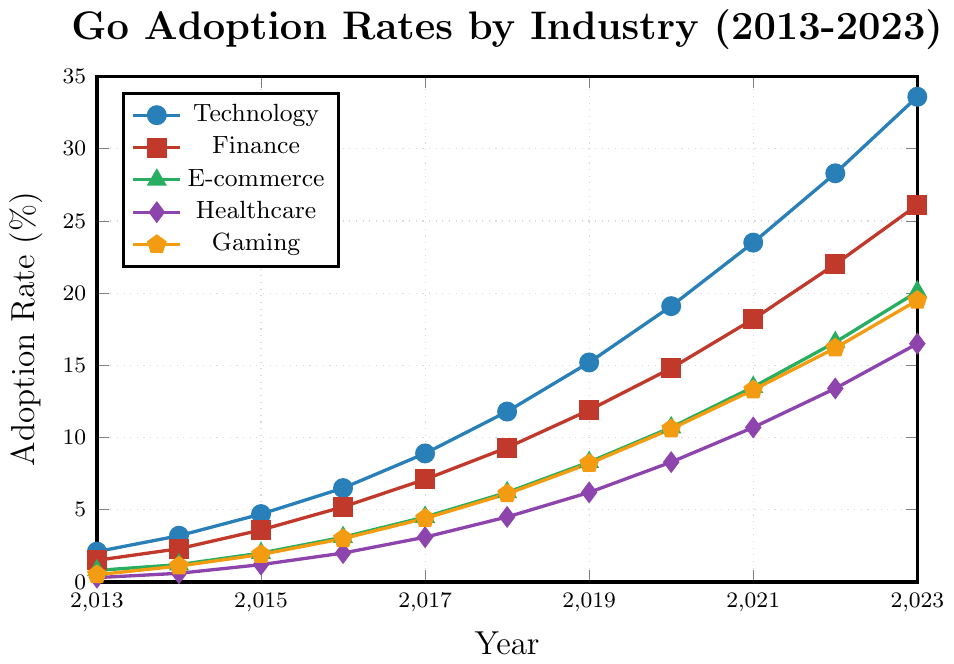What was the highest adoption rate of Go in the Technology sector across the years? From the plot, we observe that the Go adoption rate in the Technology sector reaches its highest at 33.6% in the year 2023.
Answer: 33.6% Which sector had the lowest adoption rate of Go in 2015? By looking at the plot for the year 2015, the Healthcare sector shows the lowest adoption rate of Go at 1.2%.
Answer: Healthcare By how much did the adoption rate of Go in the Finance sector increase from 2016 to 2020? The adoption rate for Finance in 2016 was 5.2% and 14.8% in 2020. The increase is calculated as 14.8 - 5.2 = 9.6%.
Answer: 9.6% What is the difference between the adoption rate of Go in the Gaming sector between 2019 and 2023? According to the plot, the adoption rate in the Gaming sector for 2019 was 8.2% and for 2023 it was 19.5%. The difference is 19.5 - 8.2 = 11.3%.
Answer: 11.3% In which year did E-commerce surpass a 10% adoption rate of Go? Referring to the E-commerce line in the plot, we see that it just surpassed 10% in 2020 with an adoption rate of 10.7%.
Answer: 2020 How much did the Healthcare sector’s adoption rate of Go increase from 2013 to 2023? For Healthcare, the adoption rate went from 0.3% in 2013 to 16.5% in 2023. The increase is 16.5 - 0.3 = 16.2%.
Answer: 16.2% Which sector saw the most significant growth in the adoption rate of Go between 2013 and 2023? By visually comparing all the sectors, the Technology sector shows the most significant growth from 2.1% in 2013 to 33.6% in 2023. This is a total increase of 33.6 - 2.1 = 31.5%.
Answer: Technology Rank the sectors by their Go adoption rates in 2023. In 2023, the Go adoption rates are: Technology (33.6%), Finance (26.1%), E-commerce (20.1%), Gaming (19.5%), and Healthcare (16.5%). Ranking them gives: Technology > Finance > E-commerce > Gaming > Healthcare.
Answer: Technology, Finance, E-commerce, Gaming, Healthcare 